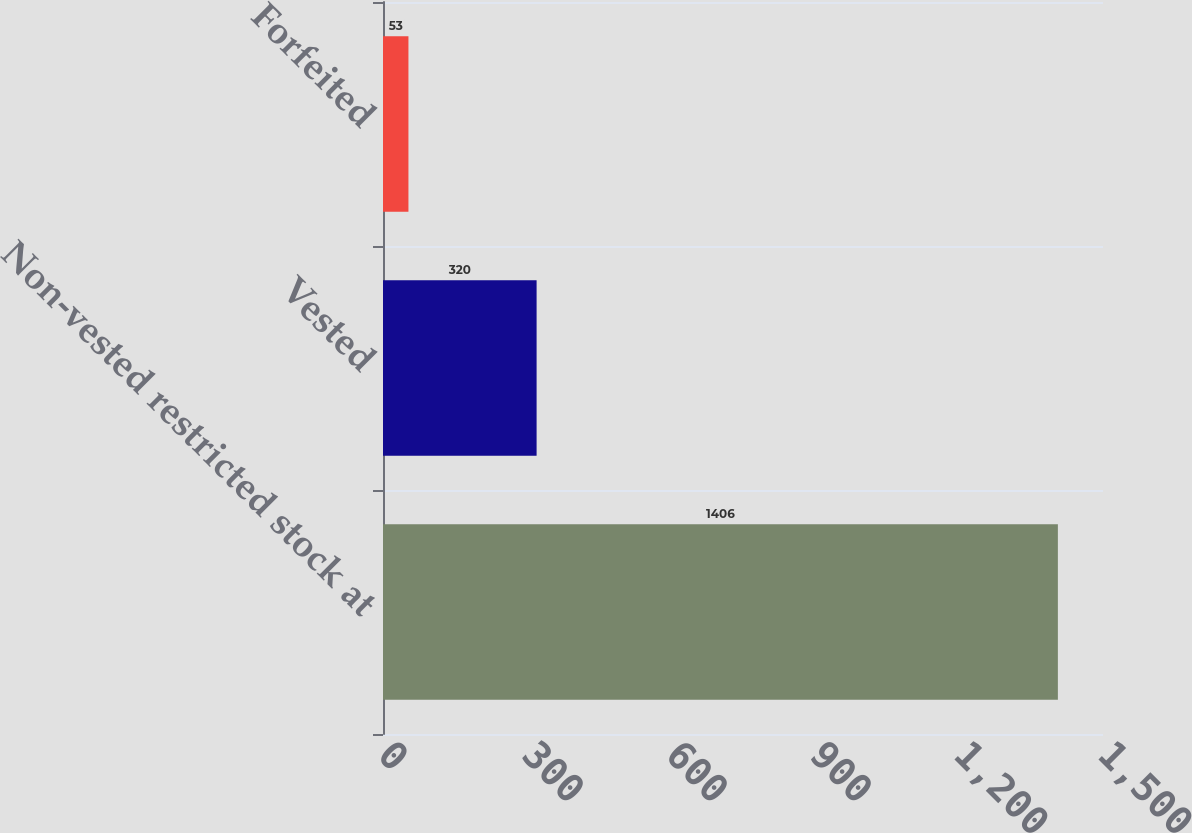Convert chart. <chart><loc_0><loc_0><loc_500><loc_500><bar_chart><fcel>Non-vested restricted stock at<fcel>Vested<fcel>Forfeited<nl><fcel>1406<fcel>320<fcel>53<nl></chart> 